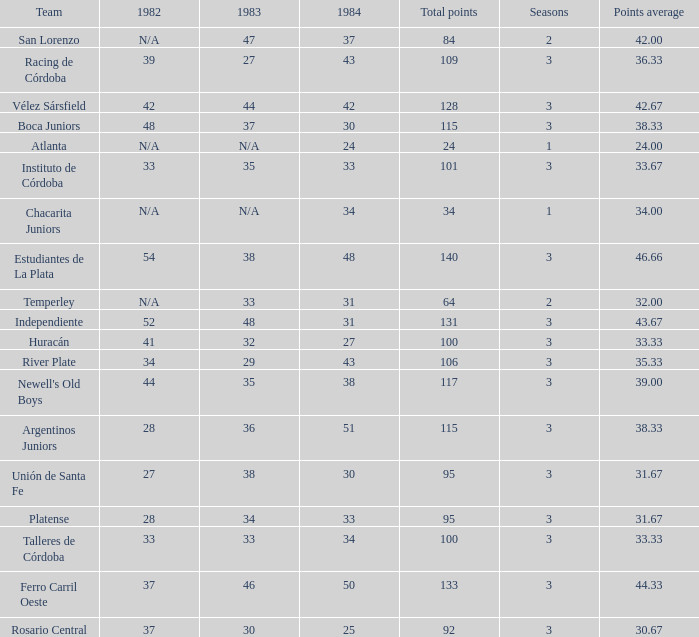What is the points total for the team with points average more than 34, 1984 score more than 37 and N/A in 1982? 0.0. 